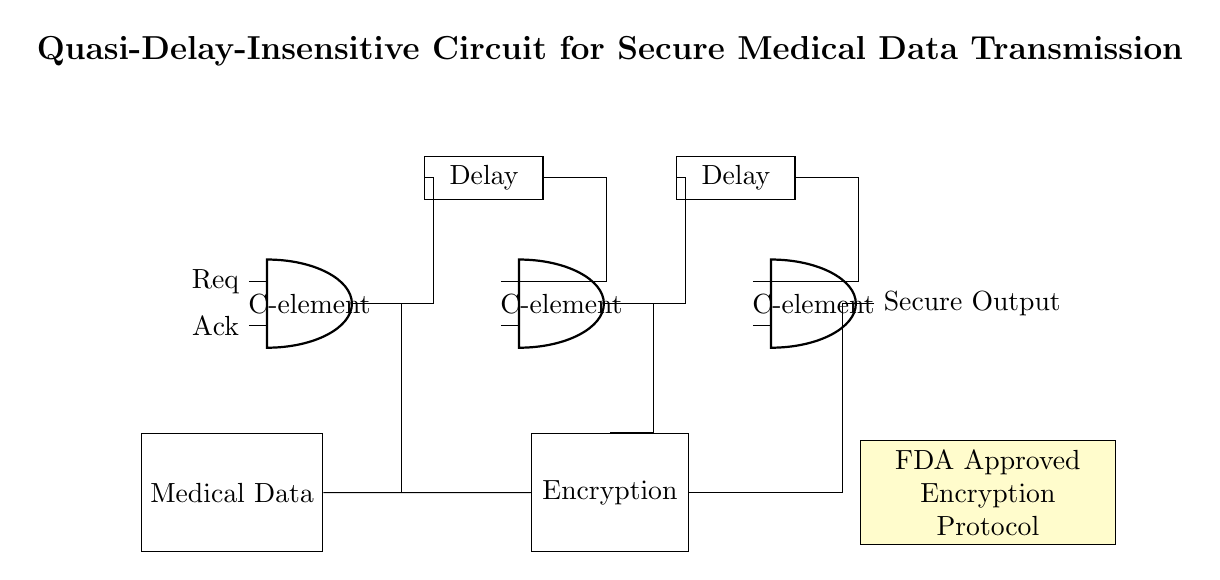What is the primary function of the encryption block? The primary function of the encryption block is to secure the medical data before transmission. This is evident as the block is labeled "Encryption" and is directly connected to the medical data input.
Answer: Secure medical data How many C-elements are present in the circuit? There are three C-elements present in the circuit, as denoted by the "C-element" labels in the diagram. Each C-element is placed in a row at the top of the diagram.
Answer: Three What does the FDA Approved Encryption Protocol note indicate? The note indicates that the encryption protocol used in the circuit has received approval from the FDA, emphasizing regulatory compliance for safe medical data transmission.
Answer: FDA Approved What type of circuit is being depicted? The circuit depicted is a quasi-delay-insensitive circuit, as denoted in the title at the top of the diagram. This type of circuit is known for its robustness against delays in signal transmission.
Answer: Quasi-delay-insensitive Describe the significance of the delay elements. The delay elements serve to synchronize signals within the circuit, allowing for stable contributions to the outputs from the C-elements. They are essential for maintaining timing integrity in asynchronous operations.
Answer: Synchronization What is the required input for the C-elements? The required inputs for the C-elements are "Req" and "Ack", which are essential signals in asynchronous circuits that indicate request and acknowledgment respectively. These inputs are labeled on the left side near the C-elements.
Answer: Req and Ack How is the secure output represented in the circuit? The secure output is represented at the right end of the circuit, marked simply as "Secure Output," indicating the end result of the processing from the C-elements and encryption.
Answer: Secure Output 